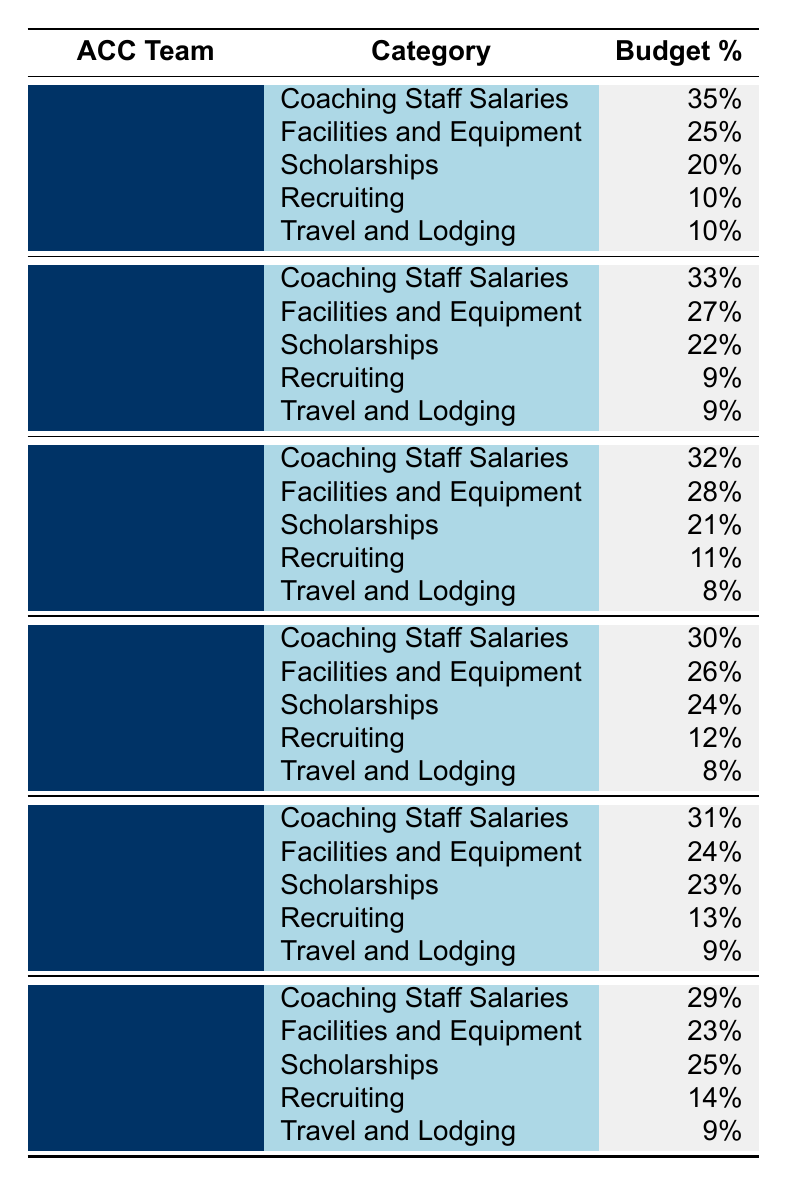What is the budget percentage allocated to Coaching Staff Salaries for Virginia Tech? From the table, Virginia Tech has Coaching Staff Salaries with a budget percentage of 31%.
Answer: 31% Which ACC team allocates the highest percentage of its budget to Scholarships? Looking at the table, North Carolina allocates 24% of its budget to Scholarships, which is the highest percentage among all teams listed.
Answer: 24% How much more budget percentage does Clemson allocate to Facilities and Equipment compared to Travel and Lodging? Clemson allocates 25% to Facilities and Equipment and 10% to Travel and Lodging. The difference is 25% - 10% = 15%.
Answer: 15% True or False: Miami spends more on Scholarships than Florida State. From the table, Miami allocates 21% to Scholarships, while Florida State allocates 22%, so it is false.
Answer: False What is the average budget percentage allocated to Recruiting across all teams listed? To find the average, we sum the Recruiting percentages (10% + 9% + 11% + 12% + 13% + 14%) = 79%. There are 6 teams, so the average is 79% / 6 ≈ 13.17%.
Answer: Approximately 13.17% Which team has the lowest budget percentage for Travel and Lodging? The table shows that Miami allocates the lowest percentage, which is 8% for Travel and Lodging.
Answer: 8% If we combine the budget percentages for Scholarships from all teams, what is the total percentage? The total percentage can be calculated by adding the Scholarship budgets: (20% + 22% + 21% + 24% + 23% + 25%) = 135%.
Answer: 135% How does Florida State's budget for Facilities and Equipment compare to North Carolina's? Florida State allocates 27% to Facilities and Equipment while North Carolina allocates 26%. The difference is 27% - 26% = 1%.
Answer: 1% What percentage of Clemson's budget is allocated to Recruiting? According to the table, Clemson allocates 10% of its budget to Recruiting.
Answer: 10% Is the total budget percentage for Coaching Staff Salaries higher or lower than that for Facilities and Equipment across all teams? Total Coaching Staff Salaries = 35% + 33% + 32% + 30% + 31% + 29% = 220%; Total Facilities and Equipment = 25% + 27% + 28% + 26% + 24% + 23% = 153%. Since 220% > 153%, it is higher.
Answer: Higher 